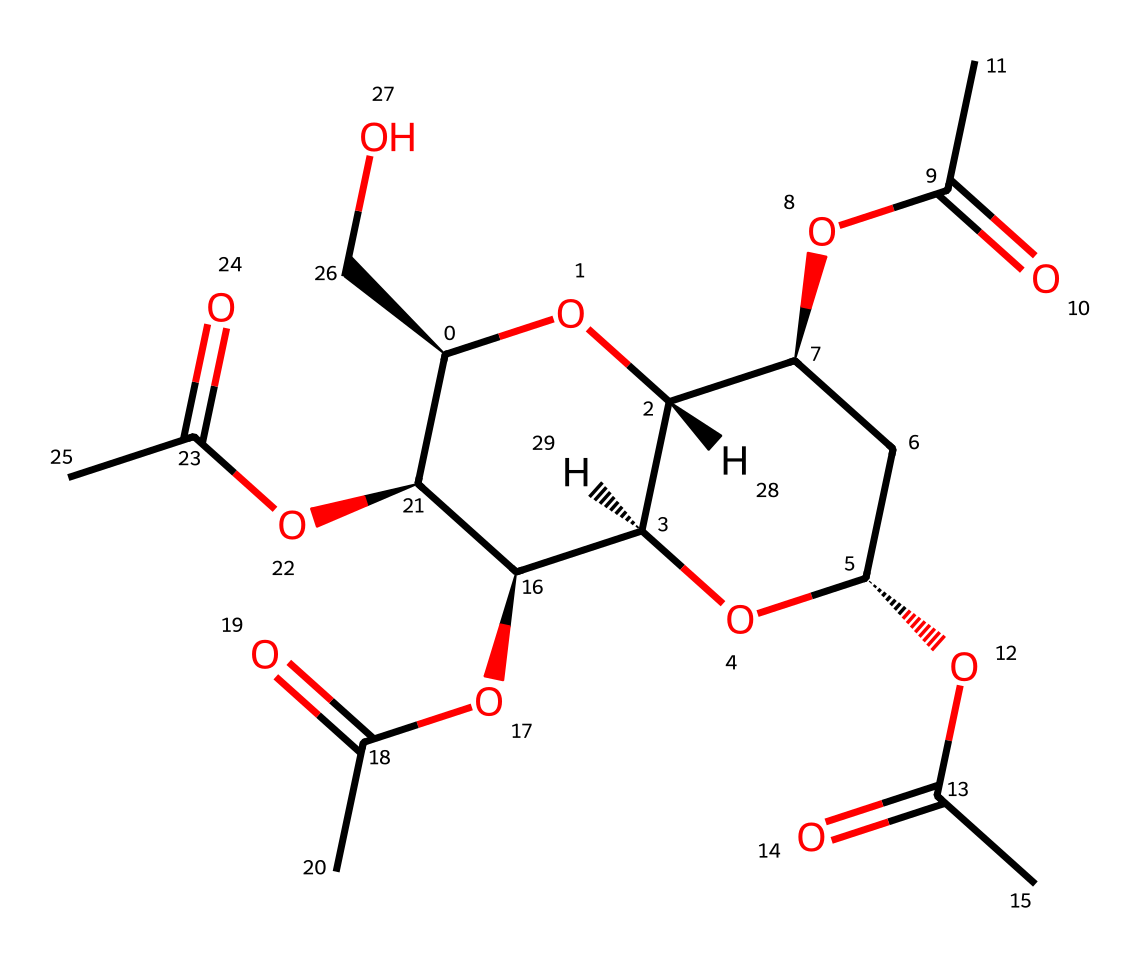What is the name of the chemical represented by this SMILES? The SMILES provided corresponds to cellulose acetate, a cellulose derivative where acetyl groups replace some hydroxyl groups.
Answer: cellulose acetate How many carbon atoms are in the structure? By analyzing the SMILES, we count a total of 9 carbon atoms (C) involved in the backbone and side groups.
Answer: 9 What type of functional groups are present in cellulose acetate? The structural representation shows ester functional groups due to the presence of the acyl (–COO–) groups attached to the cellulose backbone.
Answer: ester What is the total number of oxygen atoms in the molecule? The structure includes 6 oxygen atoms (O), calculated by identifying each 'O' in the SMILES.
Answer: 6 Which part of the molecule indicates it is soluble in organic solvents? The presence of the acetyl ester groups makes the molecule more hydrophobic, which is indicated by the carbonyl (C=O) and ether (–O–) groups that lead to solubility in organic solvents.
Answer: acetyl ester groups How many sugar units are indicated in the structure? The cellulose derivative consists of repeating sugar units; from the arrangement, 3 distinct sugar units can be identified in the structure due to the repeating pattern.
Answer: 3 